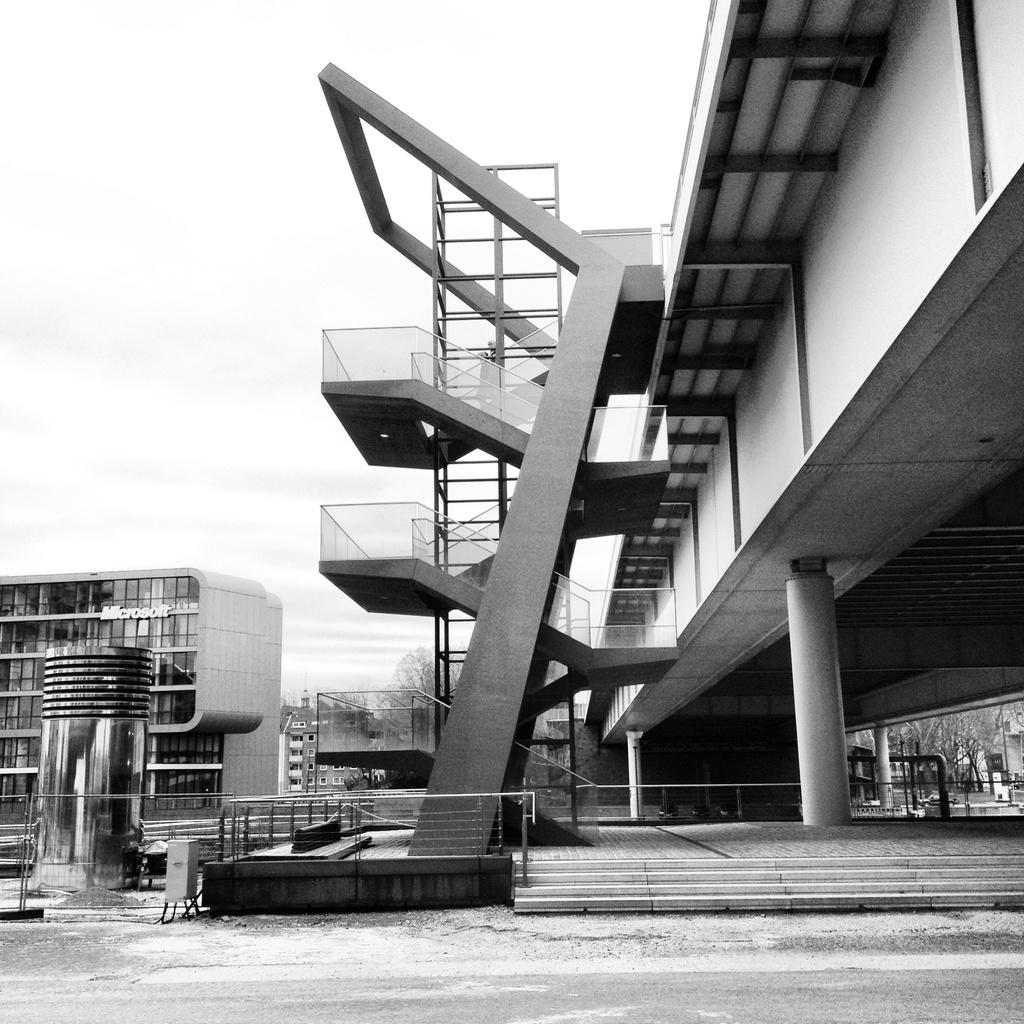What is the color scheme of the image? The image is black and white. What type of structures can be seen in the image? There are buildings and pillars in the image. What other natural elements are present in the image? There are trees in the image. What can be seen in the background of the image? The sky is visible in the background of the image. How many sacks are being used as a boundary in the image? There are no sacks or boundaries present in the image; it features buildings, pillars, trees, and a sky background. What type of planes can be seen flying in the image? There are no planes visible in the image. 